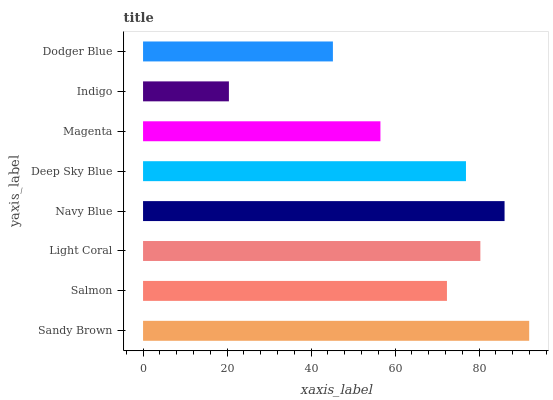Is Indigo the minimum?
Answer yes or no. Yes. Is Sandy Brown the maximum?
Answer yes or no. Yes. Is Salmon the minimum?
Answer yes or no. No. Is Salmon the maximum?
Answer yes or no. No. Is Sandy Brown greater than Salmon?
Answer yes or no. Yes. Is Salmon less than Sandy Brown?
Answer yes or no. Yes. Is Salmon greater than Sandy Brown?
Answer yes or no. No. Is Sandy Brown less than Salmon?
Answer yes or no. No. Is Deep Sky Blue the high median?
Answer yes or no. Yes. Is Salmon the low median?
Answer yes or no. Yes. Is Light Coral the high median?
Answer yes or no. No. Is Deep Sky Blue the low median?
Answer yes or no. No. 